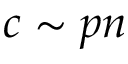Convert formula to latex. <formula><loc_0><loc_0><loc_500><loc_500>c \sim p n</formula> 